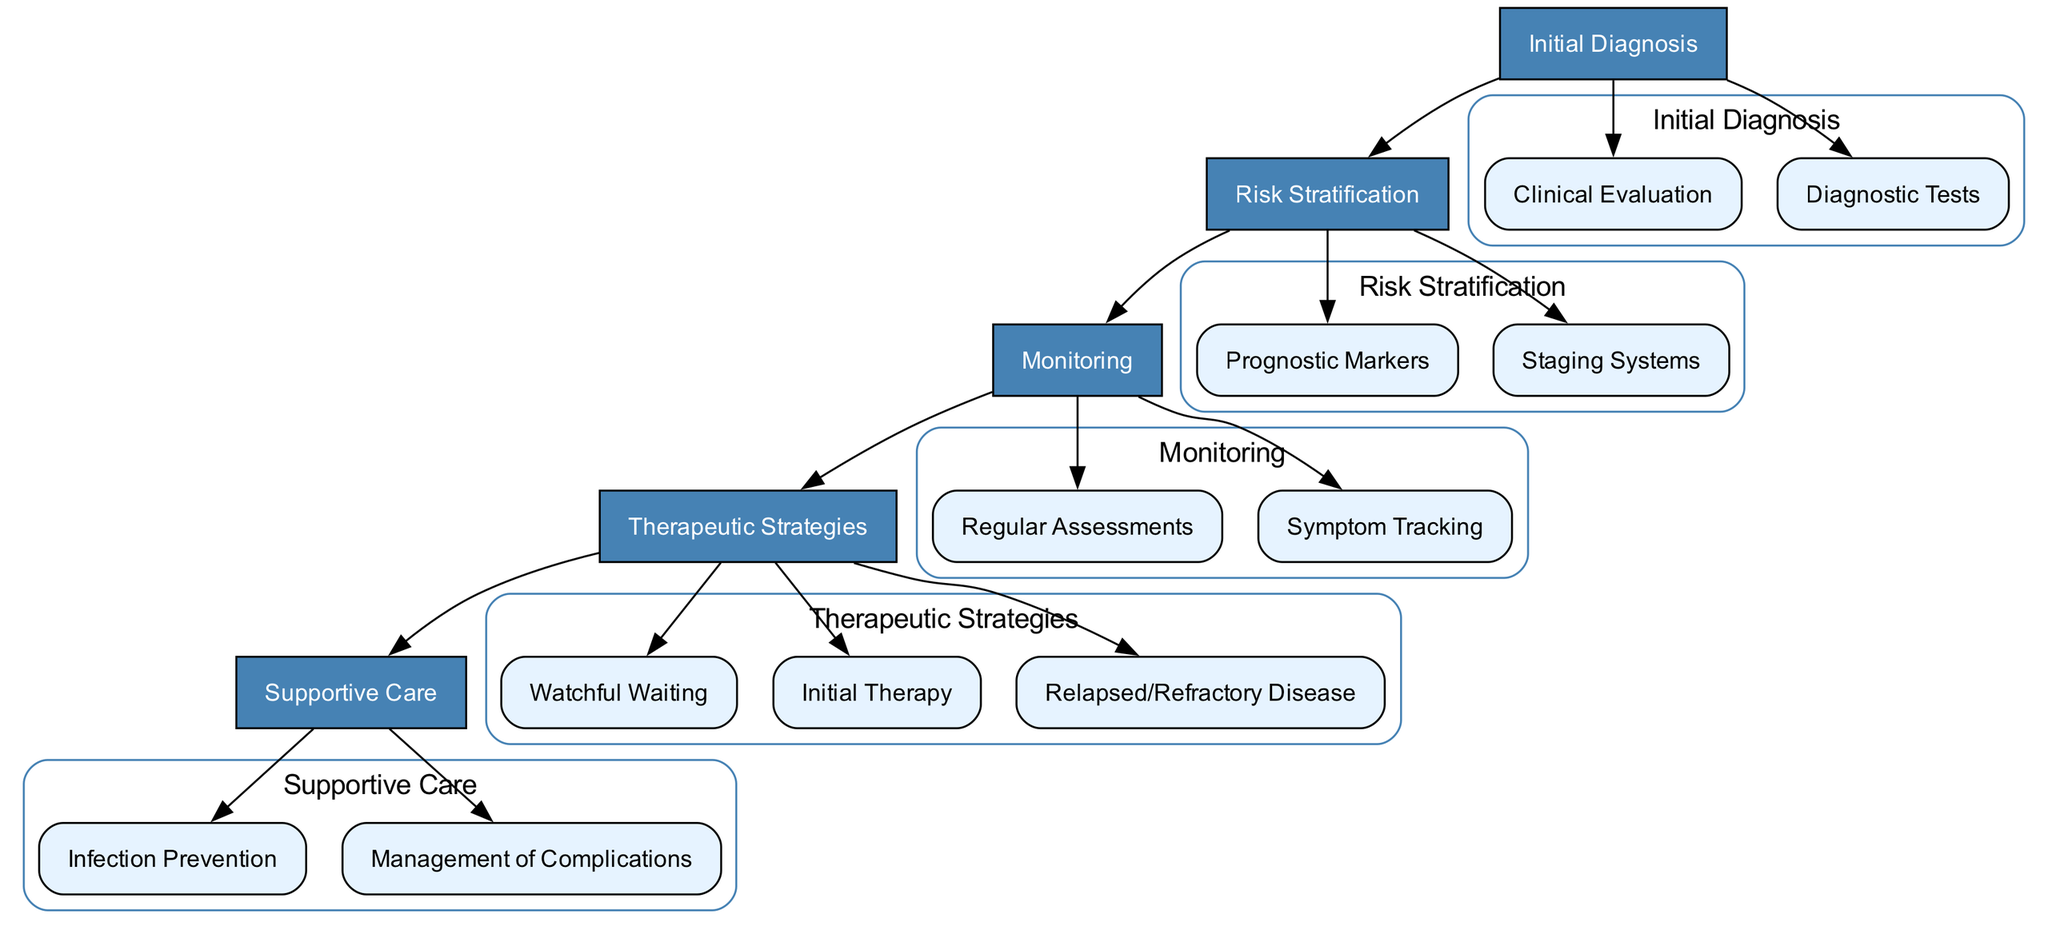What are the main stages in the clinical pathway? The main stages listed in the diagram are 'Initial Diagnosis', 'Risk Stratification', 'Monitoring', 'Therapeutic Strategies', and 'Supportive Care'.
Answer: Initial Diagnosis, Risk Stratification, Monitoring, Therapeutic Strategies, Supportive Care How many nodes are there under 'Monitoring'? Under 'Monitoring', there are two nodes: 'Regular Assessments' and 'Symptom Tracking'.
Answer: 2 What type of patients is 'Watchful Waiting' used for? 'Watchful Waiting' criteria include 'Asymptomatic Patients' and 'Low-Risk Disease', which means it is used for patients who do not show symptoms and are classified as low-risk.
Answer: Asymptomatic Patients, Low-Risk Disease Which therapeutic strategy follows after monitoring? After Monitoring, the pathway leads to 'Therapeutic Strategies', indicating that therapeutic strategies are considered after monitoring the patient's condition.
Answer: Therapeutic Strategies What kind of tests are performed during 'Initial Diagnosis'? During 'Initial Diagnosis', the tests include 'Flow Cytometry', 'Immunophenotyping', 'Genetic Studies (FISH, PCR for IGHV mutation status)', and 'Bone Marrow Biopsy'.
Answer: Flow Cytometry, Immunophenotyping, Genetic Studies (FISH, PCR for IGHV mutation status), Bone Marrow Biopsy What is a criterion for 'Second-Line Treatment' in 'Relapsed/Refractory Disease'? A criterion for 'Second-Line Treatment' is the use of 'Different Class of Targeted Agents', which indicates new treatment options are explored for patients whose disease has relapsed or is refractory.
Answer: Different Class of Targeted Agents Which staging systems are analyzed during 'Risk Stratification'? The staging systems analyzed are 'Rai Staging' and 'Binet Staging', which are used to assess the disease stage and tailor treatment appropriately.
Answer: Rai Staging, Binet Staging What are included in 'Infection Prevention' under 'Supportive Care'? 'Infection Prevention' includes 'Vaccinations', 'Antiviral Prophylaxis', and 'Antibiotic Prophylaxis', highlighting measures to prevent infections in patients.
Answer: Vaccinations, Antiviral Prophylaxis, Antibiotic Prophylaxis How often should 'CBC' be assessed under 'Regular Assessments'? Under 'Regular Assessments', 'CBC' should be performed every 3-6 months, showing the frequency of monitoring required for chronic lymphocytic leukemia patients.
Answer: Every 3-6 Months 